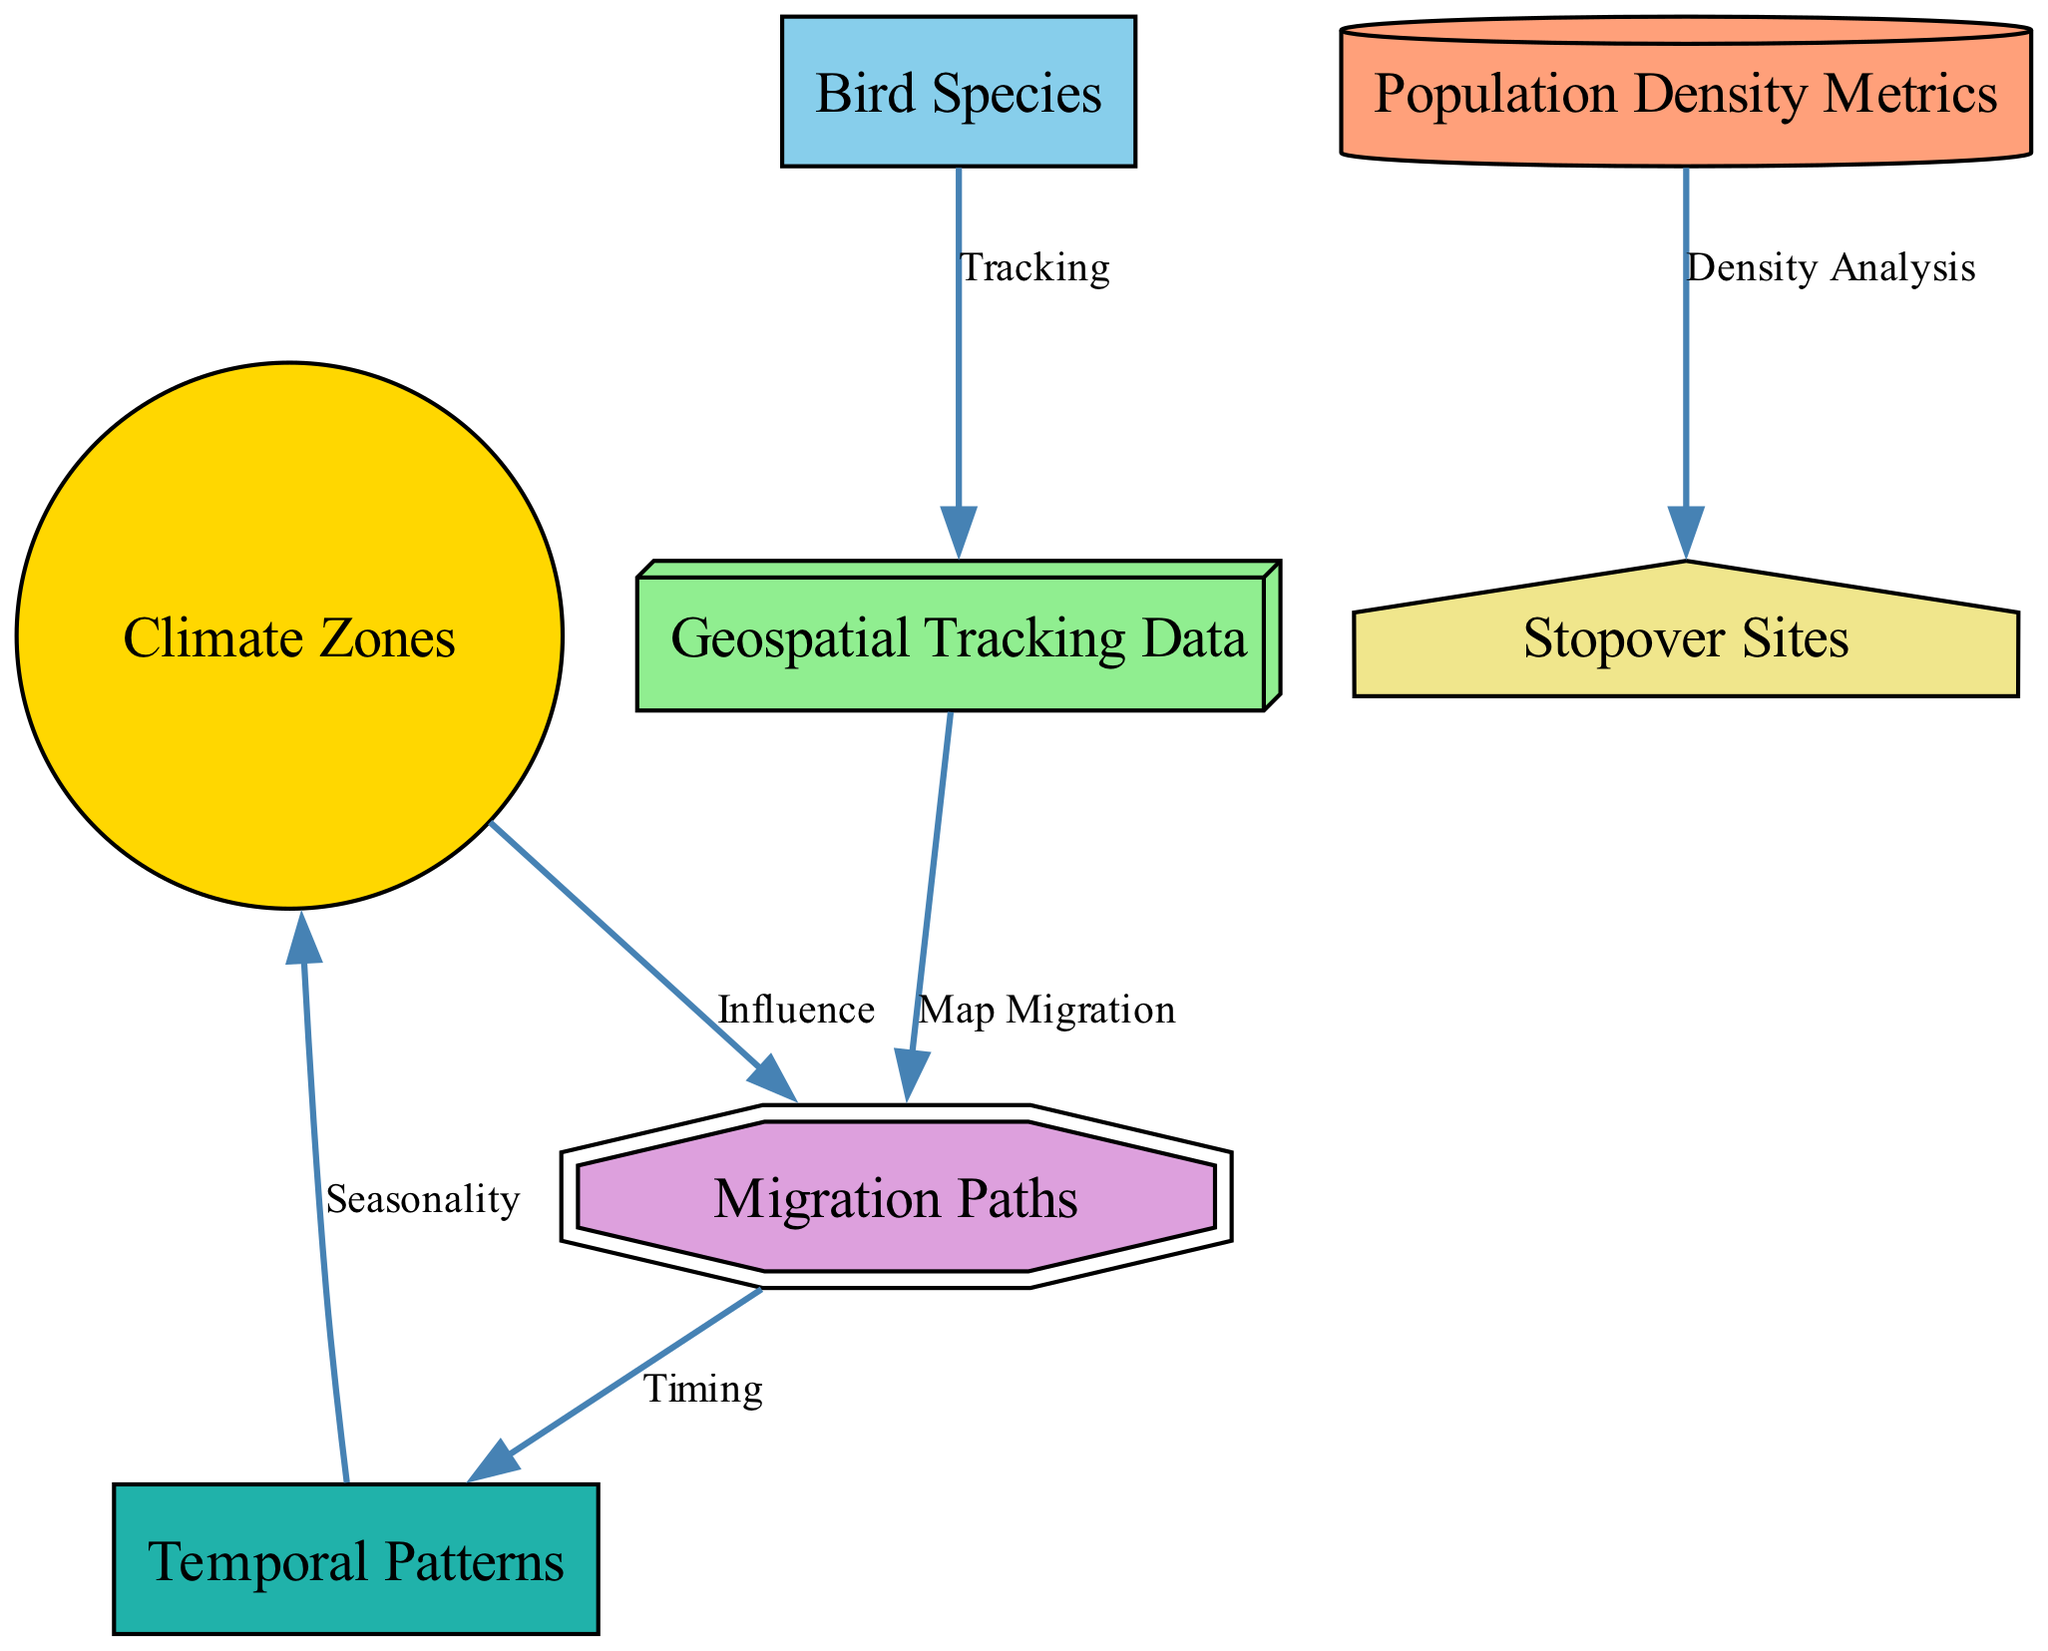What are the climate zones depicted in the diagram? The nodes labeled "Climate Zones" categorize different types of climatic regions such as tropical, temperate, and arctic. These labels are visually presented in the diagram.
Answer: tropical, temperate, arctic How many bird species are represented in the diagram? The node labeled "Bird Species" indicates that there are various bird species, but does not specify a count. Since it refers to multiple species, we can assume that the number is greater than one, even though an exact figure isn't given.
Answer: multiple What is the relationship between climate zones and migration paths? The edge between "Climate Zones" and "Migration Paths" is labeled "Influence," indicating that climate zones have an impact on the routes birds take during migration.
Answer: Influence What data is used to map migration paths? The edge connecting "Geospatial Tracking Data" to "Migration Paths" is labeled "Map Migration," which specifies that geospatial data is responsible for mapping these migration routes.
Answer: Geospatial Tracking Data Which node analyses population density? The edge from "Population Density Metrics" to "Stopover Sites" is labeled "Density Analysis," indicating that this node is responsible for analyzing the density of birds at locations where they rest during migration.
Answer: Stopover Sites How does temporal patterns relate to climate zones? The edge from "Temporal Patterns" to "Climate Zones" is labeled "Seasonality," suggesting that the timing of migrations is linked to seasonal changes in climate zones. This establishes a clear relationship between the two.
Answer: Seasonality What kind of data is tracked through geospatial tracking? The node labeled "Geospatial Tracking Data" specifically refers to data collected from GPS tracking devices on birds, indicating the type of tracking technology being discussed.
Answer: GPS tracking What does the migration paths reveal in terms of temporal patterns? The edge from "Migration Paths" to "Temporal Patterns" is labeled "Timing," which indicates that migration paths can show patterns regarding the timing and frequency of migrations corresponding to seasonal changes.
Answer: Timing Which nodes are directly associated with stopover sites? The edge from "Population Density Metrics" to "Stopover Sites" shows a direct relationship, indicating that these nodes are directly related to analyzing bird density at those locations during migration.
Answer: Population Density Metrics 